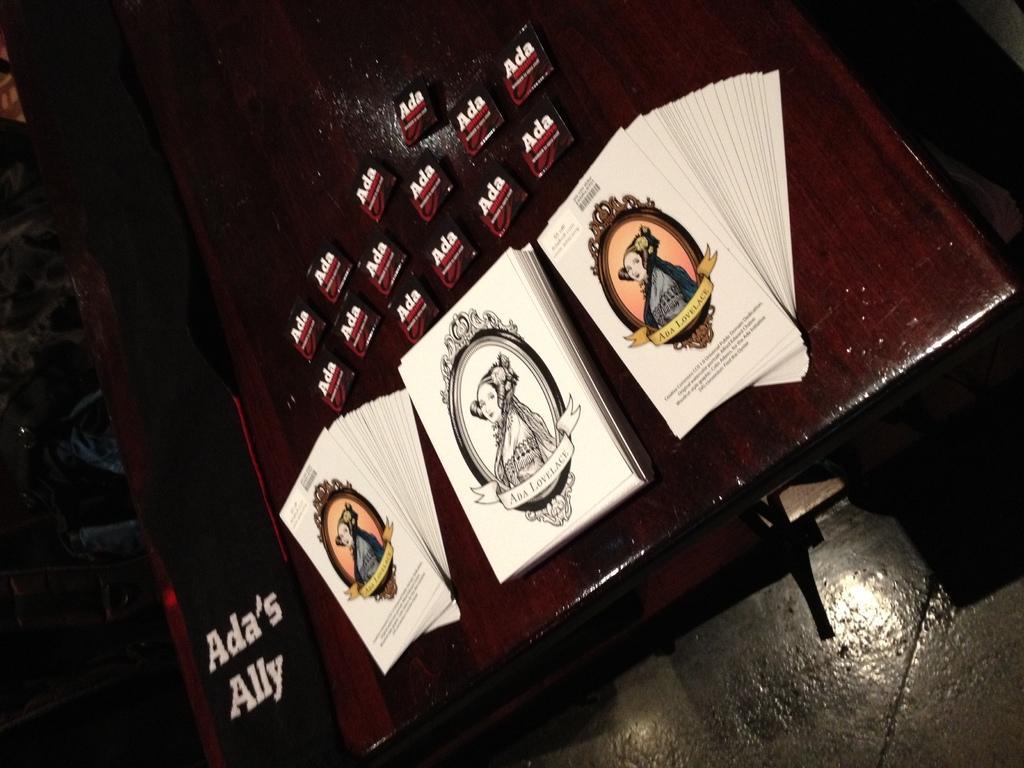Can you describe this image briefly? In this picture I can see few papers with some text and pictures on the table and I can see dark background. 